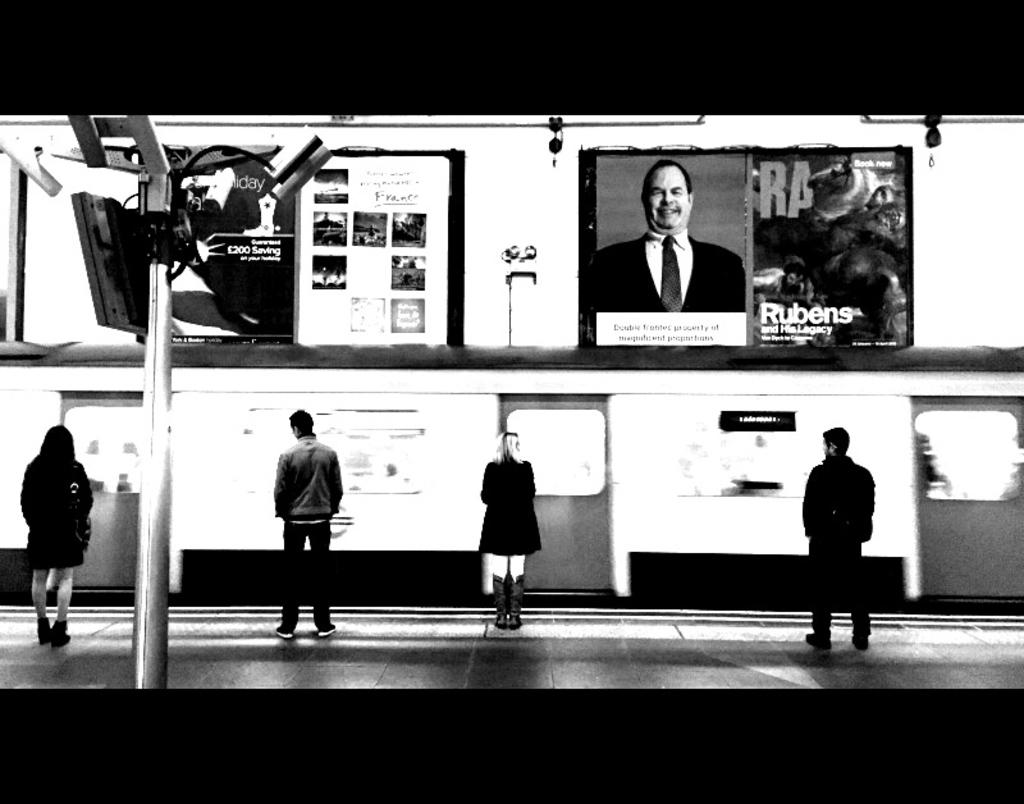What is the main subject of the image? There is a train in the image. What can be seen near the train? There are people standing on the platform. What object is visible in the image that is not related to the train or platform? A pole is visible in the image. What additional decorative elements are present in the image? Banners are present in the image. What type of bait is being used to catch fish in the image? There is no fishing or bait present in the image; it features a train and people on a platform. How many cents are visible on the train in the image? There is no mention of currency or cents in the image; it only shows a train, people, a pole, and banners. 